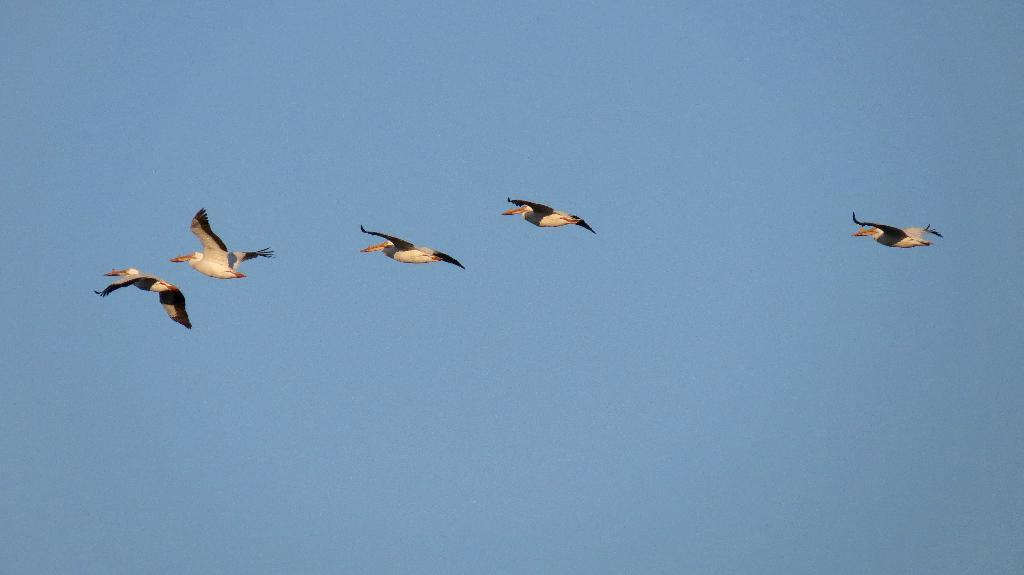How many birds are visible in the image? There are five birds in the image. What are the birds doing in the image? The birds are flying in the sky. What type of bubble can be seen floating near the birds in the image? There is no bubble present in the image; it only features five birds flying in the sky. 